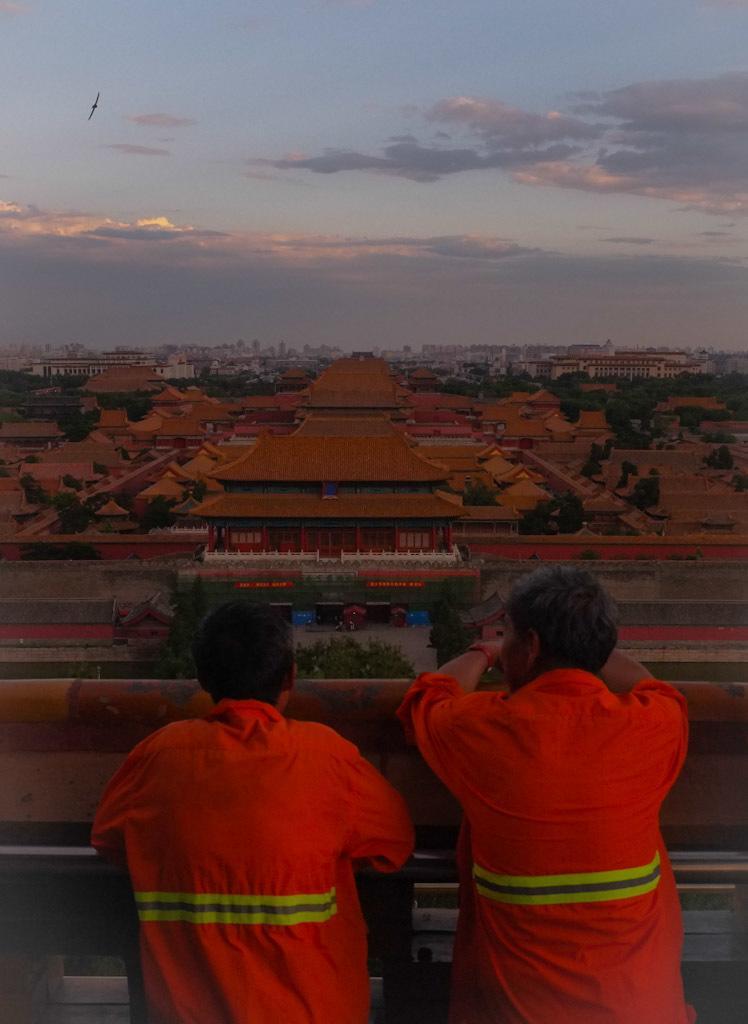Can you describe this image briefly? In this image, we can see two people are near the rod. Background we can see houses, trees, buildings, walls. Top of the image, there is a cloudy sky and bird is flying in the air. 